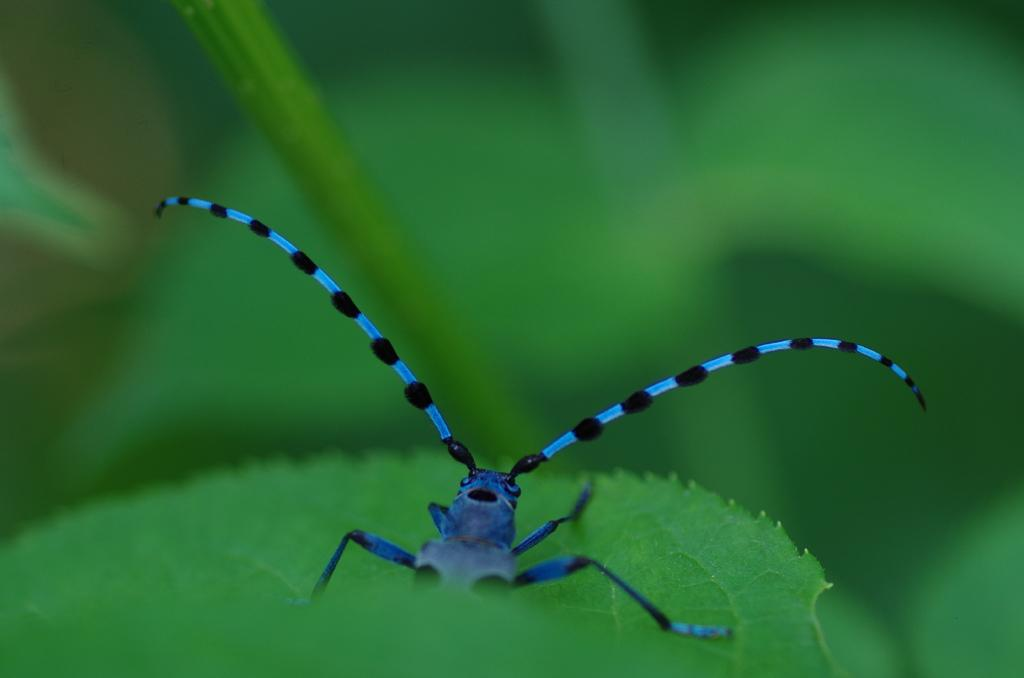What type of insect is in the image? There is a black and blue insect in the image. Where is the insect located? The insect is on a green leaf. What can be seen in the background of the image? There are green leaves in the background of the image. How would you describe the overall image quality? The image is blurred. What type of clover is the insect sitting on in the image? There is no clover present in the image; the insect is on a green leaf. What advice would you give the father in the image to get the insect's attention? There is no father present in the image, and the insect is not interacting with anyone. 